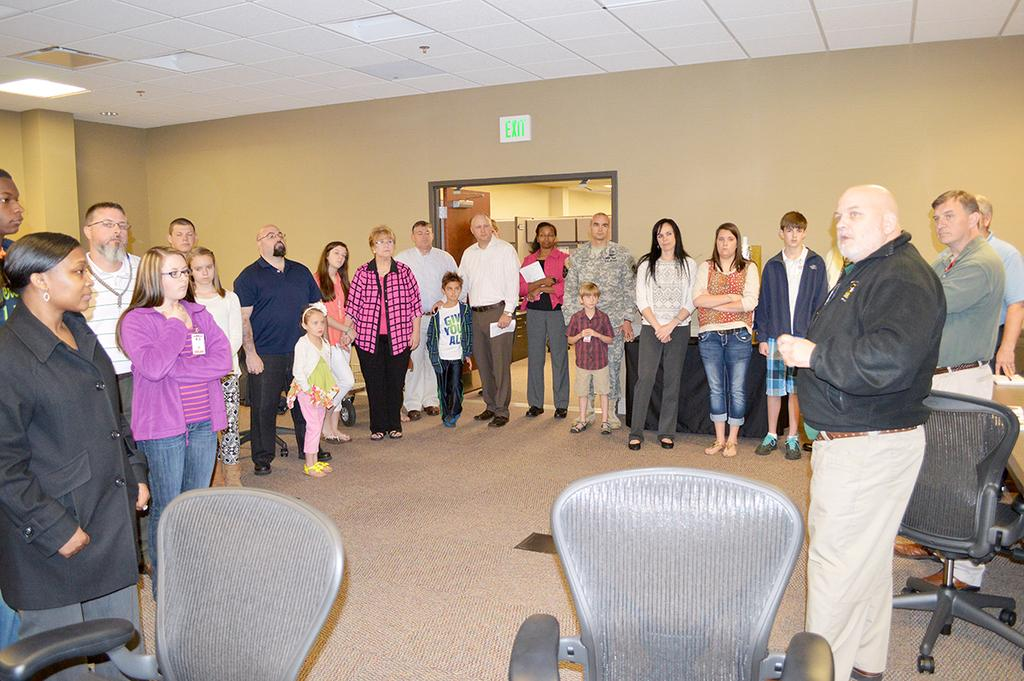What is happening in the image? There is a group of people in the image, and they are standing at the corner of a house. Can you describe the position of the man in the group? The man is standing on the right side of the group. What is the man doing in the image? The man is speaking. What type of garden can be seen in the image? There is no garden present in the image. How does the man blow bubbles in the image? The man is not blowing bubbles in the image; he is speaking. 